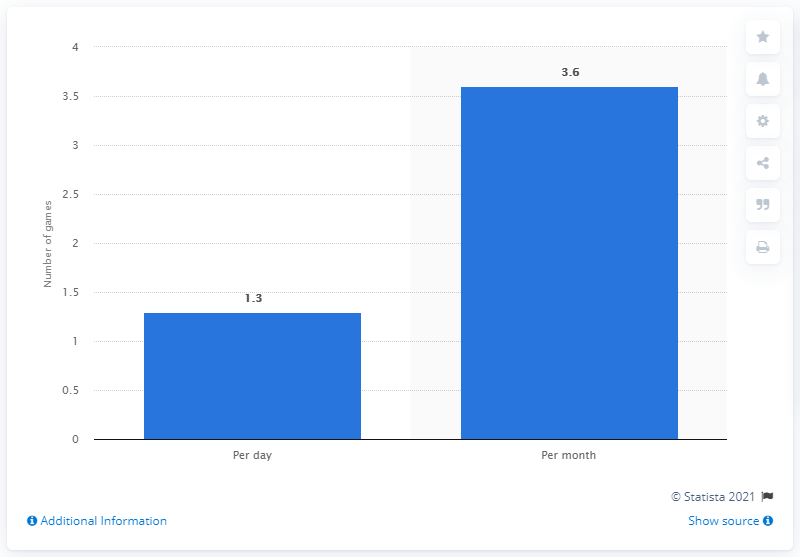Indicate a few pertinent items in this graphic. As of April 2016, the average number of mobile games played per day in the U.S. was 1.3. This information suggests that the majority of individuals in the U.S. were engaging in mobile gaming on a daily basis, with a noticeable average. 